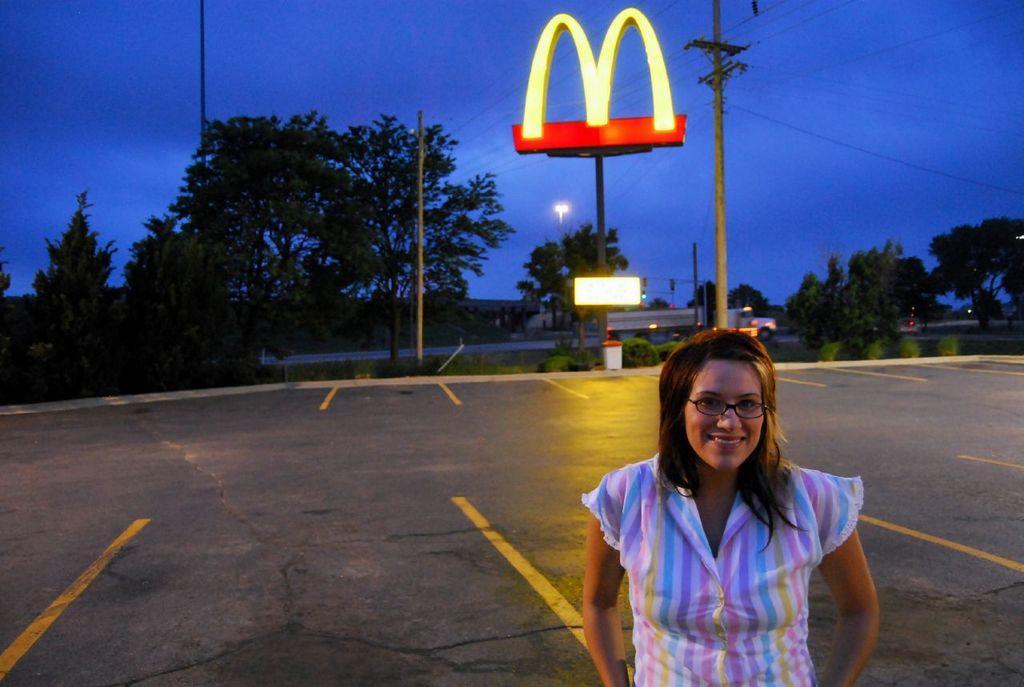Please provide a concise description of this image. This image is taken outdoors. At the bottom of the image there is a road. In the middle of the image a woman is standing on the road. In the background there are a few trees, plants, poles and a board with text on it and there is a dust bin on the road. At the top of the image there is a sky and there is a symbol of MCDonald's. 